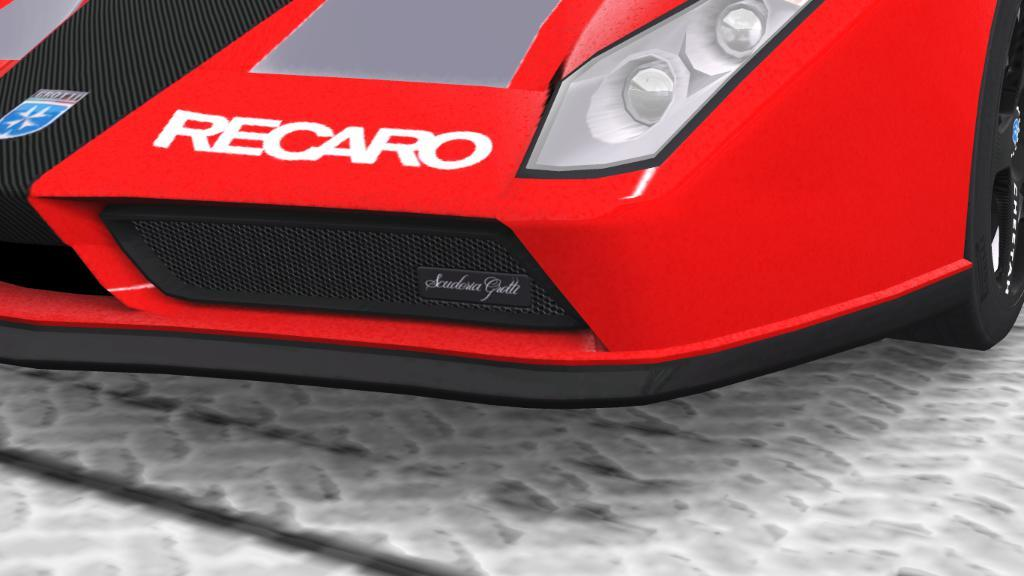What is the main subject of the image? The main subject of the image is a car. Where is the car located in the image? The car is on the floor in the image. What features can be seen on the car? The car has headlights and at least one tire visible in the image. What type of nerve can be seen connecting the car to the wall in the image? There is no nerve connecting the car to the wall in the image; it is a car on the floor with no visible connection to any wall. 